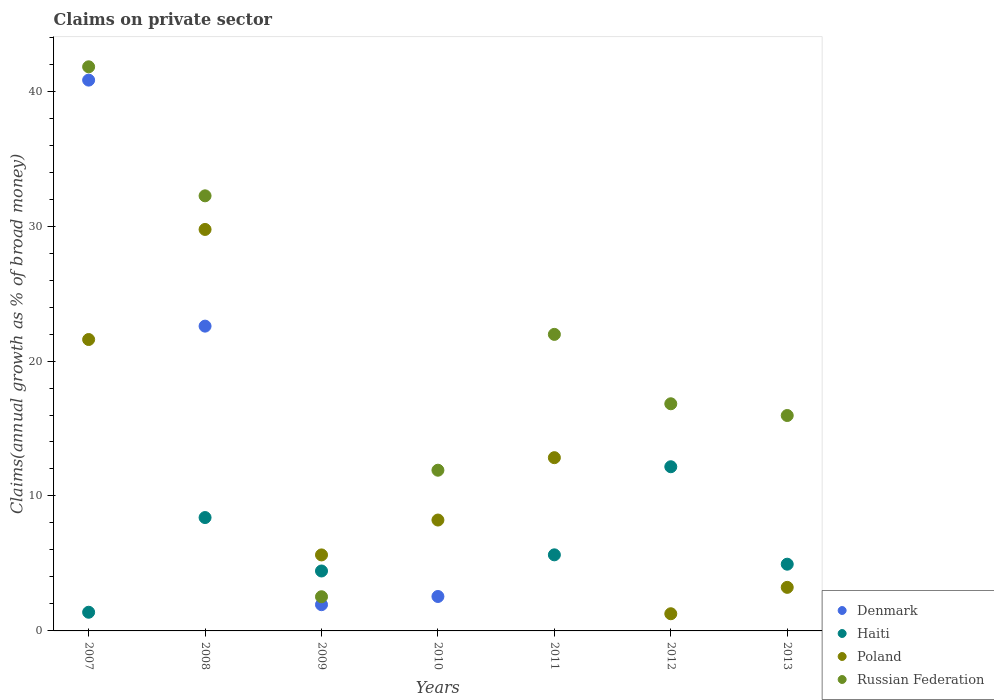How many different coloured dotlines are there?
Your answer should be very brief. 4. What is the percentage of broad money claimed on private sector in Haiti in 2009?
Provide a succinct answer. 4.44. Across all years, what is the maximum percentage of broad money claimed on private sector in Russian Federation?
Make the answer very short. 41.8. Across all years, what is the minimum percentage of broad money claimed on private sector in Poland?
Provide a succinct answer. 1.27. What is the total percentage of broad money claimed on private sector in Poland in the graph?
Your answer should be very brief. 82.53. What is the difference between the percentage of broad money claimed on private sector in Poland in 2010 and that in 2011?
Offer a very short reply. -4.62. What is the difference between the percentage of broad money claimed on private sector in Russian Federation in 2011 and the percentage of broad money claimed on private sector in Denmark in 2008?
Ensure brevity in your answer.  -0.61. What is the average percentage of broad money claimed on private sector in Haiti per year?
Make the answer very short. 5.28. In the year 2012, what is the difference between the percentage of broad money claimed on private sector in Russian Federation and percentage of broad money claimed on private sector in Poland?
Provide a short and direct response. 15.56. What is the ratio of the percentage of broad money claimed on private sector in Poland in 2007 to that in 2010?
Your answer should be very brief. 2.63. Is the percentage of broad money claimed on private sector in Poland in 2011 less than that in 2013?
Keep it short and to the point. No. What is the difference between the highest and the second highest percentage of broad money claimed on private sector in Poland?
Keep it short and to the point. 8.16. What is the difference between the highest and the lowest percentage of broad money claimed on private sector in Poland?
Offer a very short reply. 28.48. In how many years, is the percentage of broad money claimed on private sector in Poland greater than the average percentage of broad money claimed on private sector in Poland taken over all years?
Make the answer very short. 3. Is the sum of the percentage of broad money claimed on private sector in Haiti in 2007 and 2011 greater than the maximum percentage of broad money claimed on private sector in Denmark across all years?
Provide a succinct answer. No. Is it the case that in every year, the sum of the percentage of broad money claimed on private sector in Russian Federation and percentage of broad money claimed on private sector in Poland  is greater than the percentage of broad money claimed on private sector in Haiti?
Offer a terse response. Yes. Is the percentage of broad money claimed on private sector in Russian Federation strictly less than the percentage of broad money claimed on private sector in Poland over the years?
Your answer should be compact. No. How many dotlines are there?
Give a very brief answer. 4. Are the values on the major ticks of Y-axis written in scientific E-notation?
Ensure brevity in your answer.  No. Does the graph contain any zero values?
Provide a short and direct response. Yes. Does the graph contain grids?
Your answer should be very brief. No. Where does the legend appear in the graph?
Your response must be concise. Bottom right. How many legend labels are there?
Your response must be concise. 4. How are the legend labels stacked?
Make the answer very short. Vertical. What is the title of the graph?
Keep it short and to the point. Claims on private sector. Does "Turkey" appear as one of the legend labels in the graph?
Provide a short and direct response. No. What is the label or title of the Y-axis?
Make the answer very short. Claims(annual growth as % of broad money). What is the Claims(annual growth as % of broad money) in Denmark in 2007?
Offer a terse response. 40.82. What is the Claims(annual growth as % of broad money) of Haiti in 2007?
Offer a terse response. 1.38. What is the Claims(annual growth as % of broad money) of Poland in 2007?
Ensure brevity in your answer.  21.59. What is the Claims(annual growth as % of broad money) in Russian Federation in 2007?
Make the answer very short. 41.8. What is the Claims(annual growth as % of broad money) of Denmark in 2008?
Give a very brief answer. 22.59. What is the Claims(annual growth as % of broad money) of Haiti in 2008?
Provide a short and direct response. 8.4. What is the Claims(annual growth as % of broad money) in Poland in 2008?
Your answer should be very brief. 29.75. What is the Claims(annual growth as % of broad money) of Russian Federation in 2008?
Keep it short and to the point. 32.24. What is the Claims(annual growth as % of broad money) in Denmark in 2009?
Provide a short and direct response. 1.94. What is the Claims(annual growth as % of broad money) in Haiti in 2009?
Offer a very short reply. 4.44. What is the Claims(annual growth as % of broad money) in Poland in 2009?
Provide a short and direct response. 5.63. What is the Claims(annual growth as % of broad money) in Russian Federation in 2009?
Offer a very short reply. 2.53. What is the Claims(annual growth as % of broad money) of Denmark in 2010?
Your answer should be very brief. 2.55. What is the Claims(annual growth as % of broad money) in Haiti in 2010?
Provide a succinct answer. 0. What is the Claims(annual growth as % of broad money) in Poland in 2010?
Your answer should be very brief. 8.22. What is the Claims(annual growth as % of broad money) of Russian Federation in 2010?
Make the answer very short. 11.91. What is the Claims(annual growth as % of broad money) of Haiti in 2011?
Your answer should be very brief. 5.64. What is the Claims(annual growth as % of broad money) of Poland in 2011?
Your answer should be compact. 12.84. What is the Claims(annual growth as % of broad money) in Russian Federation in 2011?
Provide a succinct answer. 21.97. What is the Claims(annual growth as % of broad money) in Haiti in 2012?
Offer a very short reply. 12.17. What is the Claims(annual growth as % of broad money) of Poland in 2012?
Keep it short and to the point. 1.27. What is the Claims(annual growth as % of broad money) of Russian Federation in 2012?
Ensure brevity in your answer.  16.83. What is the Claims(annual growth as % of broad money) in Denmark in 2013?
Your answer should be very brief. 0. What is the Claims(annual growth as % of broad money) of Haiti in 2013?
Give a very brief answer. 4.94. What is the Claims(annual growth as % of broad money) of Poland in 2013?
Give a very brief answer. 3.23. What is the Claims(annual growth as % of broad money) in Russian Federation in 2013?
Your response must be concise. 15.96. Across all years, what is the maximum Claims(annual growth as % of broad money) of Denmark?
Offer a very short reply. 40.82. Across all years, what is the maximum Claims(annual growth as % of broad money) in Haiti?
Keep it short and to the point. 12.17. Across all years, what is the maximum Claims(annual growth as % of broad money) in Poland?
Offer a very short reply. 29.75. Across all years, what is the maximum Claims(annual growth as % of broad money) in Russian Federation?
Keep it short and to the point. 41.8. Across all years, what is the minimum Claims(annual growth as % of broad money) of Poland?
Keep it short and to the point. 1.27. Across all years, what is the minimum Claims(annual growth as % of broad money) of Russian Federation?
Provide a succinct answer. 2.53. What is the total Claims(annual growth as % of broad money) in Denmark in the graph?
Your answer should be compact. 67.9. What is the total Claims(annual growth as % of broad money) in Haiti in the graph?
Your response must be concise. 36.98. What is the total Claims(annual growth as % of broad money) in Poland in the graph?
Your response must be concise. 82.53. What is the total Claims(annual growth as % of broad money) in Russian Federation in the graph?
Keep it short and to the point. 143.26. What is the difference between the Claims(annual growth as % of broad money) in Denmark in 2007 and that in 2008?
Your answer should be very brief. 18.23. What is the difference between the Claims(annual growth as % of broad money) of Haiti in 2007 and that in 2008?
Offer a terse response. -7.02. What is the difference between the Claims(annual growth as % of broad money) of Poland in 2007 and that in 2008?
Your answer should be very brief. -8.16. What is the difference between the Claims(annual growth as % of broad money) in Russian Federation in 2007 and that in 2008?
Your response must be concise. 9.56. What is the difference between the Claims(annual growth as % of broad money) of Denmark in 2007 and that in 2009?
Keep it short and to the point. 38.87. What is the difference between the Claims(annual growth as % of broad money) in Haiti in 2007 and that in 2009?
Offer a very short reply. -3.06. What is the difference between the Claims(annual growth as % of broad money) in Poland in 2007 and that in 2009?
Ensure brevity in your answer.  15.96. What is the difference between the Claims(annual growth as % of broad money) in Russian Federation in 2007 and that in 2009?
Give a very brief answer. 39.27. What is the difference between the Claims(annual growth as % of broad money) in Denmark in 2007 and that in 2010?
Provide a short and direct response. 38.27. What is the difference between the Claims(annual growth as % of broad money) in Poland in 2007 and that in 2010?
Offer a terse response. 13.38. What is the difference between the Claims(annual growth as % of broad money) of Russian Federation in 2007 and that in 2010?
Offer a terse response. 29.89. What is the difference between the Claims(annual growth as % of broad money) in Haiti in 2007 and that in 2011?
Offer a very short reply. -4.25. What is the difference between the Claims(annual growth as % of broad money) in Poland in 2007 and that in 2011?
Make the answer very short. 8.76. What is the difference between the Claims(annual growth as % of broad money) of Russian Federation in 2007 and that in 2011?
Provide a short and direct response. 19.83. What is the difference between the Claims(annual growth as % of broad money) of Haiti in 2007 and that in 2012?
Make the answer very short. -10.78. What is the difference between the Claims(annual growth as % of broad money) of Poland in 2007 and that in 2012?
Provide a succinct answer. 20.32. What is the difference between the Claims(annual growth as % of broad money) in Russian Federation in 2007 and that in 2012?
Offer a terse response. 24.97. What is the difference between the Claims(annual growth as % of broad money) of Haiti in 2007 and that in 2013?
Provide a short and direct response. -3.56. What is the difference between the Claims(annual growth as % of broad money) of Poland in 2007 and that in 2013?
Provide a short and direct response. 18.37. What is the difference between the Claims(annual growth as % of broad money) of Russian Federation in 2007 and that in 2013?
Give a very brief answer. 25.84. What is the difference between the Claims(annual growth as % of broad money) in Denmark in 2008 and that in 2009?
Your answer should be very brief. 20.64. What is the difference between the Claims(annual growth as % of broad money) in Haiti in 2008 and that in 2009?
Provide a succinct answer. 3.96. What is the difference between the Claims(annual growth as % of broad money) in Poland in 2008 and that in 2009?
Your answer should be very brief. 24.12. What is the difference between the Claims(annual growth as % of broad money) in Russian Federation in 2008 and that in 2009?
Give a very brief answer. 29.71. What is the difference between the Claims(annual growth as % of broad money) in Denmark in 2008 and that in 2010?
Ensure brevity in your answer.  20.03. What is the difference between the Claims(annual growth as % of broad money) of Poland in 2008 and that in 2010?
Offer a terse response. 21.53. What is the difference between the Claims(annual growth as % of broad money) of Russian Federation in 2008 and that in 2010?
Your answer should be very brief. 20.33. What is the difference between the Claims(annual growth as % of broad money) in Haiti in 2008 and that in 2011?
Keep it short and to the point. 2.76. What is the difference between the Claims(annual growth as % of broad money) in Poland in 2008 and that in 2011?
Offer a very short reply. 16.91. What is the difference between the Claims(annual growth as % of broad money) in Russian Federation in 2008 and that in 2011?
Offer a terse response. 10.27. What is the difference between the Claims(annual growth as % of broad money) of Haiti in 2008 and that in 2012?
Your answer should be compact. -3.77. What is the difference between the Claims(annual growth as % of broad money) in Poland in 2008 and that in 2012?
Give a very brief answer. 28.48. What is the difference between the Claims(annual growth as % of broad money) of Russian Federation in 2008 and that in 2012?
Your response must be concise. 15.41. What is the difference between the Claims(annual growth as % of broad money) in Haiti in 2008 and that in 2013?
Offer a terse response. 3.46. What is the difference between the Claims(annual growth as % of broad money) of Poland in 2008 and that in 2013?
Ensure brevity in your answer.  26.52. What is the difference between the Claims(annual growth as % of broad money) of Russian Federation in 2008 and that in 2013?
Offer a terse response. 16.28. What is the difference between the Claims(annual growth as % of broad money) of Denmark in 2009 and that in 2010?
Offer a very short reply. -0.61. What is the difference between the Claims(annual growth as % of broad money) in Poland in 2009 and that in 2010?
Offer a terse response. -2.58. What is the difference between the Claims(annual growth as % of broad money) of Russian Federation in 2009 and that in 2010?
Provide a short and direct response. -9.38. What is the difference between the Claims(annual growth as % of broad money) in Haiti in 2009 and that in 2011?
Give a very brief answer. -1.2. What is the difference between the Claims(annual growth as % of broad money) of Poland in 2009 and that in 2011?
Make the answer very short. -7.21. What is the difference between the Claims(annual growth as % of broad money) in Russian Federation in 2009 and that in 2011?
Offer a very short reply. -19.44. What is the difference between the Claims(annual growth as % of broad money) in Haiti in 2009 and that in 2012?
Keep it short and to the point. -7.73. What is the difference between the Claims(annual growth as % of broad money) in Poland in 2009 and that in 2012?
Offer a very short reply. 4.36. What is the difference between the Claims(annual growth as % of broad money) of Russian Federation in 2009 and that in 2012?
Give a very brief answer. -14.3. What is the difference between the Claims(annual growth as % of broad money) in Haiti in 2009 and that in 2013?
Give a very brief answer. -0.5. What is the difference between the Claims(annual growth as % of broad money) of Poland in 2009 and that in 2013?
Ensure brevity in your answer.  2.4. What is the difference between the Claims(annual growth as % of broad money) of Russian Federation in 2009 and that in 2013?
Your answer should be very brief. -13.43. What is the difference between the Claims(annual growth as % of broad money) of Poland in 2010 and that in 2011?
Your answer should be very brief. -4.62. What is the difference between the Claims(annual growth as % of broad money) of Russian Federation in 2010 and that in 2011?
Your response must be concise. -10.07. What is the difference between the Claims(annual growth as % of broad money) of Poland in 2010 and that in 2012?
Your answer should be very brief. 6.94. What is the difference between the Claims(annual growth as % of broad money) in Russian Federation in 2010 and that in 2012?
Offer a terse response. -4.92. What is the difference between the Claims(annual growth as % of broad money) in Poland in 2010 and that in 2013?
Offer a very short reply. 4.99. What is the difference between the Claims(annual growth as % of broad money) in Russian Federation in 2010 and that in 2013?
Your answer should be compact. -4.05. What is the difference between the Claims(annual growth as % of broad money) of Haiti in 2011 and that in 2012?
Provide a short and direct response. -6.53. What is the difference between the Claims(annual growth as % of broad money) in Poland in 2011 and that in 2012?
Provide a succinct answer. 11.57. What is the difference between the Claims(annual growth as % of broad money) of Russian Federation in 2011 and that in 2012?
Provide a succinct answer. 5.14. What is the difference between the Claims(annual growth as % of broad money) in Haiti in 2011 and that in 2013?
Provide a succinct answer. 0.69. What is the difference between the Claims(annual growth as % of broad money) of Poland in 2011 and that in 2013?
Offer a terse response. 9.61. What is the difference between the Claims(annual growth as % of broad money) in Russian Federation in 2011 and that in 2013?
Provide a short and direct response. 6.01. What is the difference between the Claims(annual growth as % of broad money) in Haiti in 2012 and that in 2013?
Ensure brevity in your answer.  7.22. What is the difference between the Claims(annual growth as % of broad money) of Poland in 2012 and that in 2013?
Offer a very short reply. -1.96. What is the difference between the Claims(annual growth as % of broad money) in Russian Federation in 2012 and that in 2013?
Offer a terse response. 0.87. What is the difference between the Claims(annual growth as % of broad money) in Denmark in 2007 and the Claims(annual growth as % of broad money) in Haiti in 2008?
Ensure brevity in your answer.  32.42. What is the difference between the Claims(annual growth as % of broad money) in Denmark in 2007 and the Claims(annual growth as % of broad money) in Poland in 2008?
Your answer should be very brief. 11.07. What is the difference between the Claims(annual growth as % of broad money) of Denmark in 2007 and the Claims(annual growth as % of broad money) of Russian Federation in 2008?
Your response must be concise. 8.57. What is the difference between the Claims(annual growth as % of broad money) of Haiti in 2007 and the Claims(annual growth as % of broad money) of Poland in 2008?
Offer a terse response. -28.37. What is the difference between the Claims(annual growth as % of broad money) in Haiti in 2007 and the Claims(annual growth as % of broad money) in Russian Federation in 2008?
Keep it short and to the point. -30.86. What is the difference between the Claims(annual growth as % of broad money) of Poland in 2007 and the Claims(annual growth as % of broad money) of Russian Federation in 2008?
Your response must be concise. -10.65. What is the difference between the Claims(annual growth as % of broad money) of Denmark in 2007 and the Claims(annual growth as % of broad money) of Haiti in 2009?
Your response must be concise. 36.38. What is the difference between the Claims(annual growth as % of broad money) in Denmark in 2007 and the Claims(annual growth as % of broad money) in Poland in 2009?
Provide a succinct answer. 35.18. What is the difference between the Claims(annual growth as % of broad money) in Denmark in 2007 and the Claims(annual growth as % of broad money) in Russian Federation in 2009?
Provide a succinct answer. 38.28. What is the difference between the Claims(annual growth as % of broad money) of Haiti in 2007 and the Claims(annual growth as % of broad money) of Poland in 2009?
Your answer should be compact. -4.25. What is the difference between the Claims(annual growth as % of broad money) in Haiti in 2007 and the Claims(annual growth as % of broad money) in Russian Federation in 2009?
Keep it short and to the point. -1.15. What is the difference between the Claims(annual growth as % of broad money) of Poland in 2007 and the Claims(annual growth as % of broad money) of Russian Federation in 2009?
Your answer should be very brief. 19.06. What is the difference between the Claims(annual growth as % of broad money) of Denmark in 2007 and the Claims(annual growth as % of broad money) of Poland in 2010?
Offer a terse response. 32.6. What is the difference between the Claims(annual growth as % of broad money) of Denmark in 2007 and the Claims(annual growth as % of broad money) of Russian Federation in 2010?
Keep it short and to the point. 28.91. What is the difference between the Claims(annual growth as % of broad money) in Haiti in 2007 and the Claims(annual growth as % of broad money) in Poland in 2010?
Keep it short and to the point. -6.83. What is the difference between the Claims(annual growth as % of broad money) in Haiti in 2007 and the Claims(annual growth as % of broad money) in Russian Federation in 2010?
Ensure brevity in your answer.  -10.53. What is the difference between the Claims(annual growth as % of broad money) in Poland in 2007 and the Claims(annual growth as % of broad money) in Russian Federation in 2010?
Your response must be concise. 9.69. What is the difference between the Claims(annual growth as % of broad money) of Denmark in 2007 and the Claims(annual growth as % of broad money) of Haiti in 2011?
Keep it short and to the point. 35.18. What is the difference between the Claims(annual growth as % of broad money) in Denmark in 2007 and the Claims(annual growth as % of broad money) in Poland in 2011?
Offer a terse response. 27.98. What is the difference between the Claims(annual growth as % of broad money) in Denmark in 2007 and the Claims(annual growth as % of broad money) in Russian Federation in 2011?
Give a very brief answer. 18.84. What is the difference between the Claims(annual growth as % of broad money) of Haiti in 2007 and the Claims(annual growth as % of broad money) of Poland in 2011?
Give a very brief answer. -11.45. What is the difference between the Claims(annual growth as % of broad money) of Haiti in 2007 and the Claims(annual growth as % of broad money) of Russian Federation in 2011?
Offer a very short reply. -20.59. What is the difference between the Claims(annual growth as % of broad money) of Poland in 2007 and the Claims(annual growth as % of broad money) of Russian Federation in 2011?
Provide a short and direct response. -0.38. What is the difference between the Claims(annual growth as % of broad money) of Denmark in 2007 and the Claims(annual growth as % of broad money) of Haiti in 2012?
Provide a short and direct response. 28.65. What is the difference between the Claims(annual growth as % of broad money) of Denmark in 2007 and the Claims(annual growth as % of broad money) of Poland in 2012?
Make the answer very short. 39.54. What is the difference between the Claims(annual growth as % of broad money) of Denmark in 2007 and the Claims(annual growth as % of broad money) of Russian Federation in 2012?
Provide a short and direct response. 23.98. What is the difference between the Claims(annual growth as % of broad money) of Haiti in 2007 and the Claims(annual growth as % of broad money) of Poland in 2012?
Ensure brevity in your answer.  0.11. What is the difference between the Claims(annual growth as % of broad money) in Haiti in 2007 and the Claims(annual growth as % of broad money) in Russian Federation in 2012?
Your answer should be very brief. -15.45. What is the difference between the Claims(annual growth as % of broad money) in Poland in 2007 and the Claims(annual growth as % of broad money) in Russian Federation in 2012?
Offer a terse response. 4.76. What is the difference between the Claims(annual growth as % of broad money) in Denmark in 2007 and the Claims(annual growth as % of broad money) in Haiti in 2013?
Ensure brevity in your answer.  35.87. What is the difference between the Claims(annual growth as % of broad money) of Denmark in 2007 and the Claims(annual growth as % of broad money) of Poland in 2013?
Provide a short and direct response. 37.59. What is the difference between the Claims(annual growth as % of broad money) in Denmark in 2007 and the Claims(annual growth as % of broad money) in Russian Federation in 2013?
Give a very brief answer. 24.85. What is the difference between the Claims(annual growth as % of broad money) in Haiti in 2007 and the Claims(annual growth as % of broad money) in Poland in 2013?
Your answer should be very brief. -1.84. What is the difference between the Claims(annual growth as % of broad money) of Haiti in 2007 and the Claims(annual growth as % of broad money) of Russian Federation in 2013?
Your answer should be very brief. -14.58. What is the difference between the Claims(annual growth as % of broad money) in Poland in 2007 and the Claims(annual growth as % of broad money) in Russian Federation in 2013?
Keep it short and to the point. 5.63. What is the difference between the Claims(annual growth as % of broad money) of Denmark in 2008 and the Claims(annual growth as % of broad money) of Haiti in 2009?
Ensure brevity in your answer.  18.14. What is the difference between the Claims(annual growth as % of broad money) of Denmark in 2008 and the Claims(annual growth as % of broad money) of Poland in 2009?
Keep it short and to the point. 16.95. What is the difference between the Claims(annual growth as % of broad money) of Denmark in 2008 and the Claims(annual growth as % of broad money) of Russian Federation in 2009?
Make the answer very short. 20.05. What is the difference between the Claims(annual growth as % of broad money) in Haiti in 2008 and the Claims(annual growth as % of broad money) in Poland in 2009?
Provide a short and direct response. 2.77. What is the difference between the Claims(annual growth as % of broad money) in Haiti in 2008 and the Claims(annual growth as % of broad money) in Russian Federation in 2009?
Give a very brief answer. 5.87. What is the difference between the Claims(annual growth as % of broad money) of Poland in 2008 and the Claims(annual growth as % of broad money) of Russian Federation in 2009?
Make the answer very short. 27.22. What is the difference between the Claims(annual growth as % of broad money) in Denmark in 2008 and the Claims(annual growth as % of broad money) in Poland in 2010?
Your answer should be compact. 14.37. What is the difference between the Claims(annual growth as % of broad money) in Denmark in 2008 and the Claims(annual growth as % of broad money) in Russian Federation in 2010?
Your answer should be very brief. 10.68. What is the difference between the Claims(annual growth as % of broad money) of Haiti in 2008 and the Claims(annual growth as % of broad money) of Poland in 2010?
Make the answer very short. 0.18. What is the difference between the Claims(annual growth as % of broad money) of Haiti in 2008 and the Claims(annual growth as % of broad money) of Russian Federation in 2010?
Your response must be concise. -3.51. What is the difference between the Claims(annual growth as % of broad money) in Poland in 2008 and the Claims(annual growth as % of broad money) in Russian Federation in 2010?
Give a very brief answer. 17.84. What is the difference between the Claims(annual growth as % of broad money) of Denmark in 2008 and the Claims(annual growth as % of broad money) of Haiti in 2011?
Offer a terse response. 16.95. What is the difference between the Claims(annual growth as % of broad money) in Denmark in 2008 and the Claims(annual growth as % of broad money) in Poland in 2011?
Ensure brevity in your answer.  9.75. What is the difference between the Claims(annual growth as % of broad money) in Denmark in 2008 and the Claims(annual growth as % of broad money) in Russian Federation in 2011?
Your response must be concise. 0.61. What is the difference between the Claims(annual growth as % of broad money) of Haiti in 2008 and the Claims(annual growth as % of broad money) of Poland in 2011?
Offer a very short reply. -4.44. What is the difference between the Claims(annual growth as % of broad money) in Haiti in 2008 and the Claims(annual growth as % of broad money) in Russian Federation in 2011?
Keep it short and to the point. -13.57. What is the difference between the Claims(annual growth as % of broad money) in Poland in 2008 and the Claims(annual growth as % of broad money) in Russian Federation in 2011?
Provide a succinct answer. 7.78. What is the difference between the Claims(annual growth as % of broad money) in Denmark in 2008 and the Claims(annual growth as % of broad money) in Haiti in 2012?
Give a very brief answer. 10.42. What is the difference between the Claims(annual growth as % of broad money) of Denmark in 2008 and the Claims(annual growth as % of broad money) of Poland in 2012?
Offer a terse response. 21.31. What is the difference between the Claims(annual growth as % of broad money) of Denmark in 2008 and the Claims(annual growth as % of broad money) of Russian Federation in 2012?
Offer a terse response. 5.75. What is the difference between the Claims(annual growth as % of broad money) in Haiti in 2008 and the Claims(annual growth as % of broad money) in Poland in 2012?
Give a very brief answer. 7.13. What is the difference between the Claims(annual growth as % of broad money) in Haiti in 2008 and the Claims(annual growth as % of broad money) in Russian Federation in 2012?
Make the answer very short. -8.43. What is the difference between the Claims(annual growth as % of broad money) of Poland in 2008 and the Claims(annual growth as % of broad money) of Russian Federation in 2012?
Provide a short and direct response. 12.92. What is the difference between the Claims(annual growth as % of broad money) in Denmark in 2008 and the Claims(annual growth as % of broad money) in Haiti in 2013?
Offer a terse response. 17.64. What is the difference between the Claims(annual growth as % of broad money) in Denmark in 2008 and the Claims(annual growth as % of broad money) in Poland in 2013?
Provide a short and direct response. 19.36. What is the difference between the Claims(annual growth as % of broad money) of Denmark in 2008 and the Claims(annual growth as % of broad money) of Russian Federation in 2013?
Give a very brief answer. 6.62. What is the difference between the Claims(annual growth as % of broad money) of Haiti in 2008 and the Claims(annual growth as % of broad money) of Poland in 2013?
Keep it short and to the point. 5.17. What is the difference between the Claims(annual growth as % of broad money) in Haiti in 2008 and the Claims(annual growth as % of broad money) in Russian Federation in 2013?
Keep it short and to the point. -7.56. What is the difference between the Claims(annual growth as % of broad money) in Poland in 2008 and the Claims(annual growth as % of broad money) in Russian Federation in 2013?
Ensure brevity in your answer.  13.79. What is the difference between the Claims(annual growth as % of broad money) in Denmark in 2009 and the Claims(annual growth as % of broad money) in Poland in 2010?
Make the answer very short. -6.27. What is the difference between the Claims(annual growth as % of broad money) in Denmark in 2009 and the Claims(annual growth as % of broad money) in Russian Federation in 2010?
Provide a succinct answer. -9.96. What is the difference between the Claims(annual growth as % of broad money) of Haiti in 2009 and the Claims(annual growth as % of broad money) of Poland in 2010?
Your response must be concise. -3.78. What is the difference between the Claims(annual growth as % of broad money) of Haiti in 2009 and the Claims(annual growth as % of broad money) of Russian Federation in 2010?
Your response must be concise. -7.47. What is the difference between the Claims(annual growth as % of broad money) of Poland in 2009 and the Claims(annual growth as % of broad money) of Russian Federation in 2010?
Provide a short and direct response. -6.28. What is the difference between the Claims(annual growth as % of broad money) of Denmark in 2009 and the Claims(annual growth as % of broad money) of Haiti in 2011?
Your answer should be very brief. -3.69. What is the difference between the Claims(annual growth as % of broad money) of Denmark in 2009 and the Claims(annual growth as % of broad money) of Poland in 2011?
Make the answer very short. -10.89. What is the difference between the Claims(annual growth as % of broad money) of Denmark in 2009 and the Claims(annual growth as % of broad money) of Russian Federation in 2011?
Offer a very short reply. -20.03. What is the difference between the Claims(annual growth as % of broad money) in Haiti in 2009 and the Claims(annual growth as % of broad money) in Poland in 2011?
Your response must be concise. -8.4. What is the difference between the Claims(annual growth as % of broad money) in Haiti in 2009 and the Claims(annual growth as % of broad money) in Russian Federation in 2011?
Keep it short and to the point. -17.53. What is the difference between the Claims(annual growth as % of broad money) of Poland in 2009 and the Claims(annual growth as % of broad money) of Russian Federation in 2011?
Give a very brief answer. -16.34. What is the difference between the Claims(annual growth as % of broad money) in Denmark in 2009 and the Claims(annual growth as % of broad money) in Haiti in 2012?
Provide a succinct answer. -10.22. What is the difference between the Claims(annual growth as % of broad money) in Denmark in 2009 and the Claims(annual growth as % of broad money) in Poland in 2012?
Make the answer very short. 0.67. What is the difference between the Claims(annual growth as % of broad money) in Denmark in 2009 and the Claims(annual growth as % of broad money) in Russian Federation in 2012?
Give a very brief answer. -14.89. What is the difference between the Claims(annual growth as % of broad money) of Haiti in 2009 and the Claims(annual growth as % of broad money) of Poland in 2012?
Ensure brevity in your answer.  3.17. What is the difference between the Claims(annual growth as % of broad money) of Haiti in 2009 and the Claims(annual growth as % of broad money) of Russian Federation in 2012?
Provide a short and direct response. -12.39. What is the difference between the Claims(annual growth as % of broad money) in Poland in 2009 and the Claims(annual growth as % of broad money) in Russian Federation in 2012?
Give a very brief answer. -11.2. What is the difference between the Claims(annual growth as % of broad money) in Denmark in 2009 and the Claims(annual growth as % of broad money) in Haiti in 2013?
Your response must be concise. -3. What is the difference between the Claims(annual growth as % of broad money) in Denmark in 2009 and the Claims(annual growth as % of broad money) in Poland in 2013?
Your answer should be compact. -1.28. What is the difference between the Claims(annual growth as % of broad money) of Denmark in 2009 and the Claims(annual growth as % of broad money) of Russian Federation in 2013?
Give a very brief answer. -14.02. What is the difference between the Claims(annual growth as % of broad money) of Haiti in 2009 and the Claims(annual growth as % of broad money) of Poland in 2013?
Keep it short and to the point. 1.21. What is the difference between the Claims(annual growth as % of broad money) of Haiti in 2009 and the Claims(annual growth as % of broad money) of Russian Federation in 2013?
Your response must be concise. -11.52. What is the difference between the Claims(annual growth as % of broad money) of Poland in 2009 and the Claims(annual growth as % of broad money) of Russian Federation in 2013?
Provide a short and direct response. -10.33. What is the difference between the Claims(annual growth as % of broad money) of Denmark in 2010 and the Claims(annual growth as % of broad money) of Haiti in 2011?
Provide a short and direct response. -3.09. What is the difference between the Claims(annual growth as % of broad money) of Denmark in 2010 and the Claims(annual growth as % of broad money) of Poland in 2011?
Offer a very short reply. -10.29. What is the difference between the Claims(annual growth as % of broad money) of Denmark in 2010 and the Claims(annual growth as % of broad money) of Russian Federation in 2011?
Offer a very short reply. -19.42. What is the difference between the Claims(annual growth as % of broad money) of Poland in 2010 and the Claims(annual growth as % of broad money) of Russian Federation in 2011?
Make the answer very short. -13.76. What is the difference between the Claims(annual growth as % of broad money) in Denmark in 2010 and the Claims(annual growth as % of broad money) in Haiti in 2012?
Offer a terse response. -9.62. What is the difference between the Claims(annual growth as % of broad money) in Denmark in 2010 and the Claims(annual growth as % of broad money) in Poland in 2012?
Your answer should be very brief. 1.28. What is the difference between the Claims(annual growth as % of broad money) in Denmark in 2010 and the Claims(annual growth as % of broad money) in Russian Federation in 2012?
Keep it short and to the point. -14.28. What is the difference between the Claims(annual growth as % of broad money) in Poland in 2010 and the Claims(annual growth as % of broad money) in Russian Federation in 2012?
Ensure brevity in your answer.  -8.62. What is the difference between the Claims(annual growth as % of broad money) of Denmark in 2010 and the Claims(annual growth as % of broad money) of Haiti in 2013?
Make the answer very short. -2.39. What is the difference between the Claims(annual growth as % of broad money) in Denmark in 2010 and the Claims(annual growth as % of broad money) in Poland in 2013?
Keep it short and to the point. -0.68. What is the difference between the Claims(annual growth as % of broad money) of Denmark in 2010 and the Claims(annual growth as % of broad money) of Russian Federation in 2013?
Offer a terse response. -13.41. What is the difference between the Claims(annual growth as % of broad money) in Poland in 2010 and the Claims(annual growth as % of broad money) in Russian Federation in 2013?
Provide a succinct answer. -7.75. What is the difference between the Claims(annual growth as % of broad money) in Haiti in 2011 and the Claims(annual growth as % of broad money) in Poland in 2012?
Your answer should be very brief. 4.37. What is the difference between the Claims(annual growth as % of broad money) of Haiti in 2011 and the Claims(annual growth as % of broad money) of Russian Federation in 2012?
Ensure brevity in your answer.  -11.19. What is the difference between the Claims(annual growth as % of broad money) of Poland in 2011 and the Claims(annual growth as % of broad money) of Russian Federation in 2012?
Your response must be concise. -3.99. What is the difference between the Claims(annual growth as % of broad money) of Haiti in 2011 and the Claims(annual growth as % of broad money) of Poland in 2013?
Ensure brevity in your answer.  2.41. What is the difference between the Claims(annual growth as % of broad money) of Haiti in 2011 and the Claims(annual growth as % of broad money) of Russian Federation in 2013?
Offer a terse response. -10.32. What is the difference between the Claims(annual growth as % of broad money) in Poland in 2011 and the Claims(annual growth as % of broad money) in Russian Federation in 2013?
Offer a very short reply. -3.12. What is the difference between the Claims(annual growth as % of broad money) of Haiti in 2012 and the Claims(annual growth as % of broad money) of Poland in 2013?
Keep it short and to the point. 8.94. What is the difference between the Claims(annual growth as % of broad money) of Haiti in 2012 and the Claims(annual growth as % of broad money) of Russian Federation in 2013?
Your answer should be very brief. -3.8. What is the difference between the Claims(annual growth as % of broad money) in Poland in 2012 and the Claims(annual growth as % of broad money) in Russian Federation in 2013?
Offer a terse response. -14.69. What is the average Claims(annual growth as % of broad money) in Denmark per year?
Offer a terse response. 9.7. What is the average Claims(annual growth as % of broad money) of Haiti per year?
Your answer should be compact. 5.28. What is the average Claims(annual growth as % of broad money) in Poland per year?
Provide a succinct answer. 11.79. What is the average Claims(annual growth as % of broad money) in Russian Federation per year?
Provide a short and direct response. 20.47. In the year 2007, what is the difference between the Claims(annual growth as % of broad money) in Denmark and Claims(annual growth as % of broad money) in Haiti?
Make the answer very short. 39.43. In the year 2007, what is the difference between the Claims(annual growth as % of broad money) of Denmark and Claims(annual growth as % of broad money) of Poland?
Give a very brief answer. 19.22. In the year 2007, what is the difference between the Claims(annual growth as % of broad money) of Denmark and Claims(annual growth as % of broad money) of Russian Federation?
Ensure brevity in your answer.  -0.99. In the year 2007, what is the difference between the Claims(annual growth as % of broad money) of Haiti and Claims(annual growth as % of broad money) of Poland?
Provide a succinct answer. -20.21. In the year 2007, what is the difference between the Claims(annual growth as % of broad money) of Haiti and Claims(annual growth as % of broad money) of Russian Federation?
Keep it short and to the point. -40.42. In the year 2007, what is the difference between the Claims(annual growth as % of broad money) in Poland and Claims(annual growth as % of broad money) in Russian Federation?
Give a very brief answer. -20.21. In the year 2008, what is the difference between the Claims(annual growth as % of broad money) of Denmark and Claims(annual growth as % of broad money) of Haiti?
Your response must be concise. 14.19. In the year 2008, what is the difference between the Claims(annual growth as % of broad money) in Denmark and Claims(annual growth as % of broad money) in Poland?
Offer a very short reply. -7.17. In the year 2008, what is the difference between the Claims(annual growth as % of broad money) in Denmark and Claims(annual growth as % of broad money) in Russian Federation?
Your answer should be very brief. -9.66. In the year 2008, what is the difference between the Claims(annual growth as % of broad money) in Haiti and Claims(annual growth as % of broad money) in Poland?
Give a very brief answer. -21.35. In the year 2008, what is the difference between the Claims(annual growth as % of broad money) of Haiti and Claims(annual growth as % of broad money) of Russian Federation?
Keep it short and to the point. -23.84. In the year 2008, what is the difference between the Claims(annual growth as % of broad money) in Poland and Claims(annual growth as % of broad money) in Russian Federation?
Your answer should be compact. -2.49. In the year 2009, what is the difference between the Claims(annual growth as % of broad money) of Denmark and Claims(annual growth as % of broad money) of Haiti?
Make the answer very short. -2.5. In the year 2009, what is the difference between the Claims(annual growth as % of broad money) in Denmark and Claims(annual growth as % of broad money) in Poland?
Ensure brevity in your answer.  -3.69. In the year 2009, what is the difference between the Claims(annual growth as % of broad money) of Denmark and Claims(annual growth as % of broad money) of Russian Federation?
Ensure brevity in your answer.  -0.59. In the year 2009, what is the difference between the Claims(annual growth as % of broad money) of Haiti and Claims(annual growth as % of broad money) of Poland?
Make the answer very short. -1.19. In the year 2009, what is the difference between the Claims(annual growth as % of broad money) in Haiti and Claims(annual growth as % of broad money) in Russian Federation?
Keep it short and to the point. 1.91. In the year 2009, what is the difference between the Claims(annual growth as % of broad money) of Poland and Claims(annual growth as % of broad money) of Russian Federation?
Keep it short and to the point. 3.1. In the year 2010, what is the difference between the Claims(annual growth as % of broad money) in Denmark and Claims(annual growth as % of broad money) in Poland?
Your answer should be very brief. -5.67. In the year 2010, what is the difference between the Claims(annual growth as % of broad money) of Denmark and Claims(annual growth as % of broad money) of Russian Federation?
Make the answer very short. -9.36. In the year 2010, what is the difference between the Claims(annual growth as % of broad money) in Poland and Claims(annual growth as % of broad money) in Russian Federation?
Ensure brevity in your answer.  -3.69. In the year 2011, what is the difference between the Claims(annual growth as % of broad money) of Haiti and Claims(annual growth as % of broad money) of Poland?
Ensure brevity in your answer.  -7.2. In the year 2011, what is the difference between the Claims(annual growth as % of broad money) of Haiti and Claims(annual growth as % of broad money) of Russian Federation?
Ensure brevity in your answer.  -16.34. In the year 2011, what is the difference between the Claims(annual growth as % of broad money) of Poland and Claims(annual growth as % of broad money) of Russian Federation?
Offer a very short reply. -9.14. In the year 2012, what is the difference between the Claims(annual growth as % of broad money) of Haiti and Claims(annual growth as % of broad money) of Poland?
Provide a short and direct response. 10.89. In the year 2012, what is the difference between the Claims(annual growth as % of broad money) in Haiti and Claims(annual growth as % of broad money) in Russian Federation?
Ensure brevity in your answer.  -4.67. In the year 2012, what is the difference between the Claims(annual growth as % of broad money) in Poland and Claims(annual growth as % of broad money) in Russian Federation?
Offer a very short reply. -15.56. In the year 2013, what is the difference between the Claims(annual growth as % of broad money) of Haiti and Claims(annual growth as % of broad money) of Poland?
Keep it short and to the point. 1.72. In the year 2013, what is the difference between the Claims(annual growth as % of broad money) of Haiti and Claims(annual growth as % of broad money) of Russian Federation?
Provide a short and direct response. -11.02. In the year 2013, what is the difference between the Claims(annual growth as % of broad money) in Poland and Claims(annual growth as % of broad money) in Russian Federation?
Ensure brevity in your answer.  -12.73. What is the ratio of the Claims(annual growth as % of broad money) of Denmark in 2007 to that in 2008?
Offer a very short reply. 1.81. What is the ratio of the Claims(annual growth as % of broad money) of Haiti in 2007 to that in 2008?
Ensure brevity in your answer.  0.16. What is the ratio of the Claims(annual growth as % of broad money) in Poland in 2007 to that in 2008?
Your answer should be very brief. 0.73. What is the ratio of the Claims(annual growth as % of broad money) of Russian Federation in 2007 to that in 2008?
Ensure brevity in your answer.  1.3. What is the ratio of the Claims(annual growth as % of broad money) of Denmark in 2007 to that in 2009?
Provide a short and direct response. 20.99. What is the ratio of the Claims(annual growth as % of broad money) in Haiti in 2007 to that in 2009?
Make the answer very short. 0.31. What is the ratio of the Claims(annual growth as % of broad money) in Poland in 2007 to that in 2009?
Keep it short and to the point. 3.83. What is the ratio of the Claims(annual growth as % of broad money) of Russian Federation in 2007 to that in 2009?
Give a very brief answer. 16.5. What is the ratio of the Claims(annual growth as % of broad money) of Denmark in 2007 to that in 2010?
Ensure brevity in your answer.  16. What is the ratio of the Claims(annual growth as % of broad money) in Poland in 2007 to that in 2010?
Your answer should be compact. 2.63. What is the ratio of the Claims(annual growth as % of broad money) of Russian Federation in 2007 to that in 2010?
Offer a very short reply. 3.51. What is the ratio of the Claims(annual growth as % of broad money) in Haiti in 2007 to that in 2011?
Your answer should be compact. 0.25. What is the ratio of the Claims(annual growth as % of broad money) in Poland in 2007 to that in 2011?
Make the answer very short. 1.68. What is the ratio of the Claims(annual growth as % of broad money) in Russian Federation in 2007 to that in 2011?
Give a very brief answer. 1.9. What is the ratio of the Claims(annual growth as % of broad money) in Haiti in 2007 to that in 2012?
Offer a very short reply. 0.11. What is the ratio of the Claims(annual growth as % of broad money) in Poland in 2007 to that in 2012?
Ensure brevity in your answer.  16.96. What is the ratio of the Claims(annual growth as % of broad money) of Russian Federation in 2007 to that in 2012?
Your answer should be very brief. 2.48. What is the ratio of the Claims(annual growth as % of broad money) of Haiti in 2007 to that in 2013?
Give a very brief answer. 0.28. What is the ratio of the Claims(annual growth as % of broad money) in Poland in 2007 to that in 2013?
Offer a very short reply. 6.69. What is the ratio of the Claims(annual growth as % of broad money) in Russian Federation in 2007 to that in 2013?
Keep it short and to the point. 2.62. What is the ratio of the Claims(annual growth as % of broad money) in Denmark in 2008 to that in 2009?
Give a very brief answer. 11.61. What is the ratio of the Claims(annual growth as % of broad money) of Haiti in 2008 to that in 2009?
Keep it short and to the point. 1.89. What is the ratio of the Claims(annual growth as % of broad money) in Poland in 2008 to that in 2009?
Provide a short and direct response. 5.28. What is the ratio of the Claims(annual growth as % of broad money) of Russian Federation in 2008 to that in 2009?
Ensure brevity in your answer.  12.73. What is the ratio of the Claims(annual growth as % of broad money) in Denmark in 2008 to that in 2010?
Your answer should be very brief. 8.85. What is the ratio of the Claims(annual growth as % of broad money) of Poland in 2008 to that in 2010?
Offer a terse response. 3.62. What is the ratio of the Claims(annual growth as % of broad money) in Russian Federation in 2008 to that in 2010?
Provide a short and direct response. 2.71. What is the ratio of the Claims(annual growth as % of broad money) in Haiti in 2008 to that in 2011?
Ensure brevity in your answer.  1.49. What is the ratio of the Claims(annual growth as % of broad money) in Poland in 2008 to that in 2011?
Provide a short and direct response. 2.32. What is the ratio of the Claims(annual growth as % of broad money) in Russian Federation in 2008 to that in 2011?
Provide a succinct answer. 1.47. What is the ratio of the Claims(annual growth as % of broad money) of Haiti in 2008 to that in 2012?
Offer a terse response. 0.69. What is the ratio of the Claims(annual growth as % of broad money) in Poland in 2008 to that in 2012?
Make the answer very short. 23.37. What is the ratio of the Claims(annual growth as % of broad money) in Russian Federation in 2008 to that in 2012?
Give a very brief answer. 1.92. What is the ratio of the Claims(annual growth as % of broad money) of Haiti in 2008 to that in 2013?
Offer a terse response. 1.7. What is the ratio of the Claims(annual growth as % of broad money) in Poland in 2008 to that in 2013?
Keep it short and to the point. 9.22. What is the ratio of the Claims(annual growth as % of broad money) of Russian Federation in 2008 to that in 2013?
Your response must be concise. 2.02. What is the ratio of the Claims(annual growth as % of broad money) in Denmark in 2009 to that in 2010?
Your response must be concise. 0.76. What is the ratio of the Claims(annual growth as % of broad money) of Poland in 2009 to that in 2010?
Your response must be concise. 0.69. What is the ratio of the Claims(annual growth as % of broad money) in Russian Federation in 2009 to that in 2010?
Ensure brevity in your answer.  0.21. What is the ratio of the Claims(annual growth as % of broad money) of Haiti in 2009 to that in 2011?
Provide a short and direct response. 0.79. What is the ratio of the Claims(annual growth as % of broad money) in Poland in 2009 to that in 2011?
Your answer should be compact. 0.44. What is the ratio of the Claims(annual growth as % of broad money) of Russian Federation in 2009 to that in 2011?
Ensure brevity in your answer.  0.12. What is the ratio of the Claims(annual growth as % of broad money) in Haiti in 2009 to that in 2012?
Provide a succinct answer. 0.36. What is the ratio of the Claims(annual growth as % of broad money) of Poland in 2009 to that in 2012?
Give a very brief answer. 4.42. What is the ratio of the Claims(annual growth as % of broad money) in Russian Federation in 2009 to that in 2012?
Give a very brief answer. 0.15. What is the ratio of the Claims(annual growth as % of broad money) of Haiti in 2009 to that in 2013?
Make the answer very short. 0.9. What is the ratio of the Claims(annual growth as % of broad money) in Poland in 2009 to that in 2013?
Your response must be concise. 1.74. What is the ratio of the Claims(annual growth as % of broad money) in Russian Federation in 2009 to that in 2013?
Provide a short and direct response. 0.16. What is the ratio of the Claims(annual growth as % of broad money) in Poland in 2010 to that in 2011?
Offer a terse response. 0.64. What is the ratio of the Claims(annual growth as % of broad money) of Russian Federation in 2010 to that in 2011?
Offer a very short reply. 0.54. What is the ratio of the Claims(annual growth as % of broad money) in Poland in 2010 to that in 2012?
Provide a succinct answer. 6.45. What is the ratio of the Claims(annual growth as % of broad money) of Russian Federation in 2010 to that in 2012?
Give a very brief answer. 0.71. What is the ratio of the Claims(annual growth as % of broad money) in Poland in 2010 to that in 2013?
Your answer should be compact. 2.55. What is the ratio of the Claims(annual growth as % of broad money) in Russian Federation in 2010 to that in 2013?
Your answer should be very brief. 0.75. What is the ratio of the Claims(annual growth as % of broad money) of Haiti in 2011 to that in 2012?
Your answer should be compact. 0.46. What is the ratio of the Claims(annual growth as % of broad money) in Poland in 2011 to that in 2012?
Make the answer very short. 10.08. What is the ratio of the Claims(annual growth as % of broad money) of Russian Federation in 2011 to that in 2012?
Provide a short and direct response. 1.31. What is the ratio of the Claims(annual growth as % of broad money) of Haiti in 2011 to that in 2013?
Give a very brief answer. 1.14. What is the ratio of the Claims(annual growth as % of broad money) in Poland in 2011 to that in 2013?
Your answer should be very brief. 3.98. What is the ratio of the Claims(annual growth as % of broad money) of Russian Federation in 2011 to that in 2013?
Provide a succinct answer. 1.38. What is the ratio of the Claims(annual growth as % of broad money) in Haiti in 2012 to that in 2013?
Keep it short and to the point. 2.46. What is the ratio of the Claims(annual growth as % of broad money) of Poland in 2012 to that in 2013?
Provide a short and direct response. 0.39. What is the ratio of the Claims(annual growth as % of broad money) in Russian Federation in 2012 to that in 2013?
Keep it short and to the point. 1.05. What is the difference between the highest and the second highest Claims(annual growth as % of broad money) of Denmark?
Offer a terse response. 18.23. What is the difference between the highest and the second highest Claims(annual growth as % of broad money) of Haiti?
Your answer should be very brief. 3.77. What is the difference between the highest and the second highest Claims(annual growth as % of broad money) in Poland?
Give a very brief answer. 8.16. What is the difference between the highest and the second highest Claims(annual growth as % of broad money) of Russian Federation?
Your answer should be very brief. 9.56. What is the difference between the highest and the lowest Claims(annual growth as % of broad money) in Denmark?
Ensure brevity in your answer.  40.82. What is the difference between the highest and the lowest Claims(annual growth as % of broad money) of Haiti?
Provide a succinct answer. 12.17. What is the difference between the highest and the lowest Claims(annual growth as % of broad money) of Poland?
Provide a succinct answer. 28.48. What is the difference between the highest and the lowest Claims(annual growth as % of broad money) in Russian Federation?
Give a very brief answer. 39.27. 